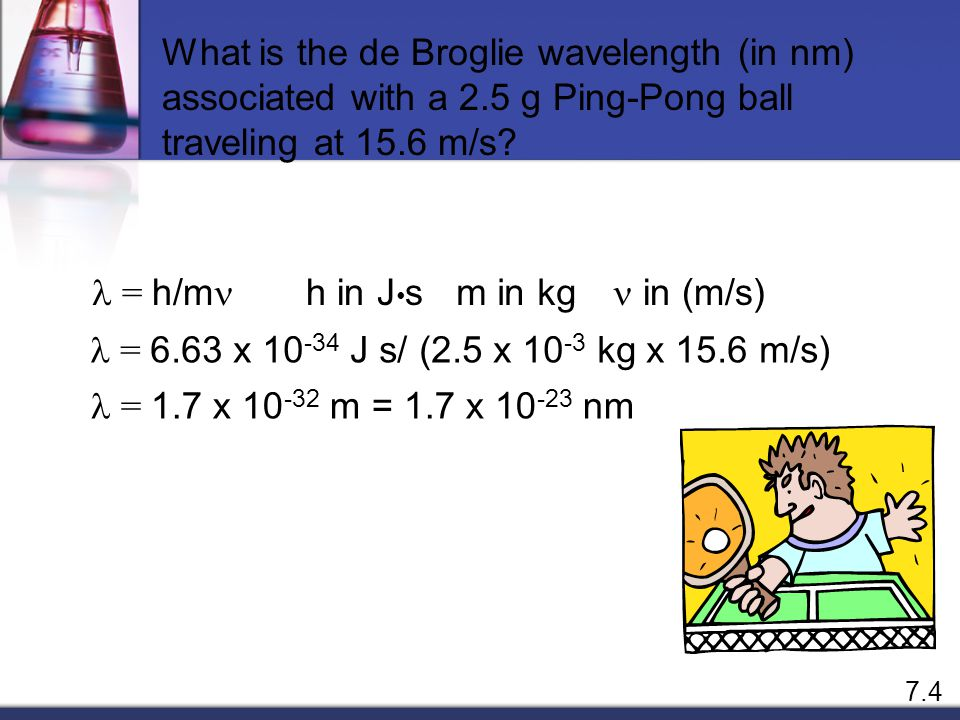Why might the image include a cartoon of a boy playing ping-pong in relation to the de Broglie wavelength concept? The cartoon of a boy playing ping-pong in the image is strategically chosen to make the abstract concept of de Broglie wavelengths more accessible and engaging. Since the de Broglie wavelength formula λ = h/mv suggests that all matter has a wavelength, albeit often incredibly tiny, using a ping-pong ball—a common, everyday item—helps illustrate this point vividly. The moving ping-pong ball, associated with mass (m) and velocity (v), offers a tangible example through which students can grasp the otherwise challenging quantum mechanics concept. The boy’s surprised expression hints at the surprising and unintuitive nature of quantum phenomena, helping to trigger curiosity and deeper inquiry into the subject. This visual metaphor serves not only to educate but also to spark interest and discussion among students learning this foundational theory. 